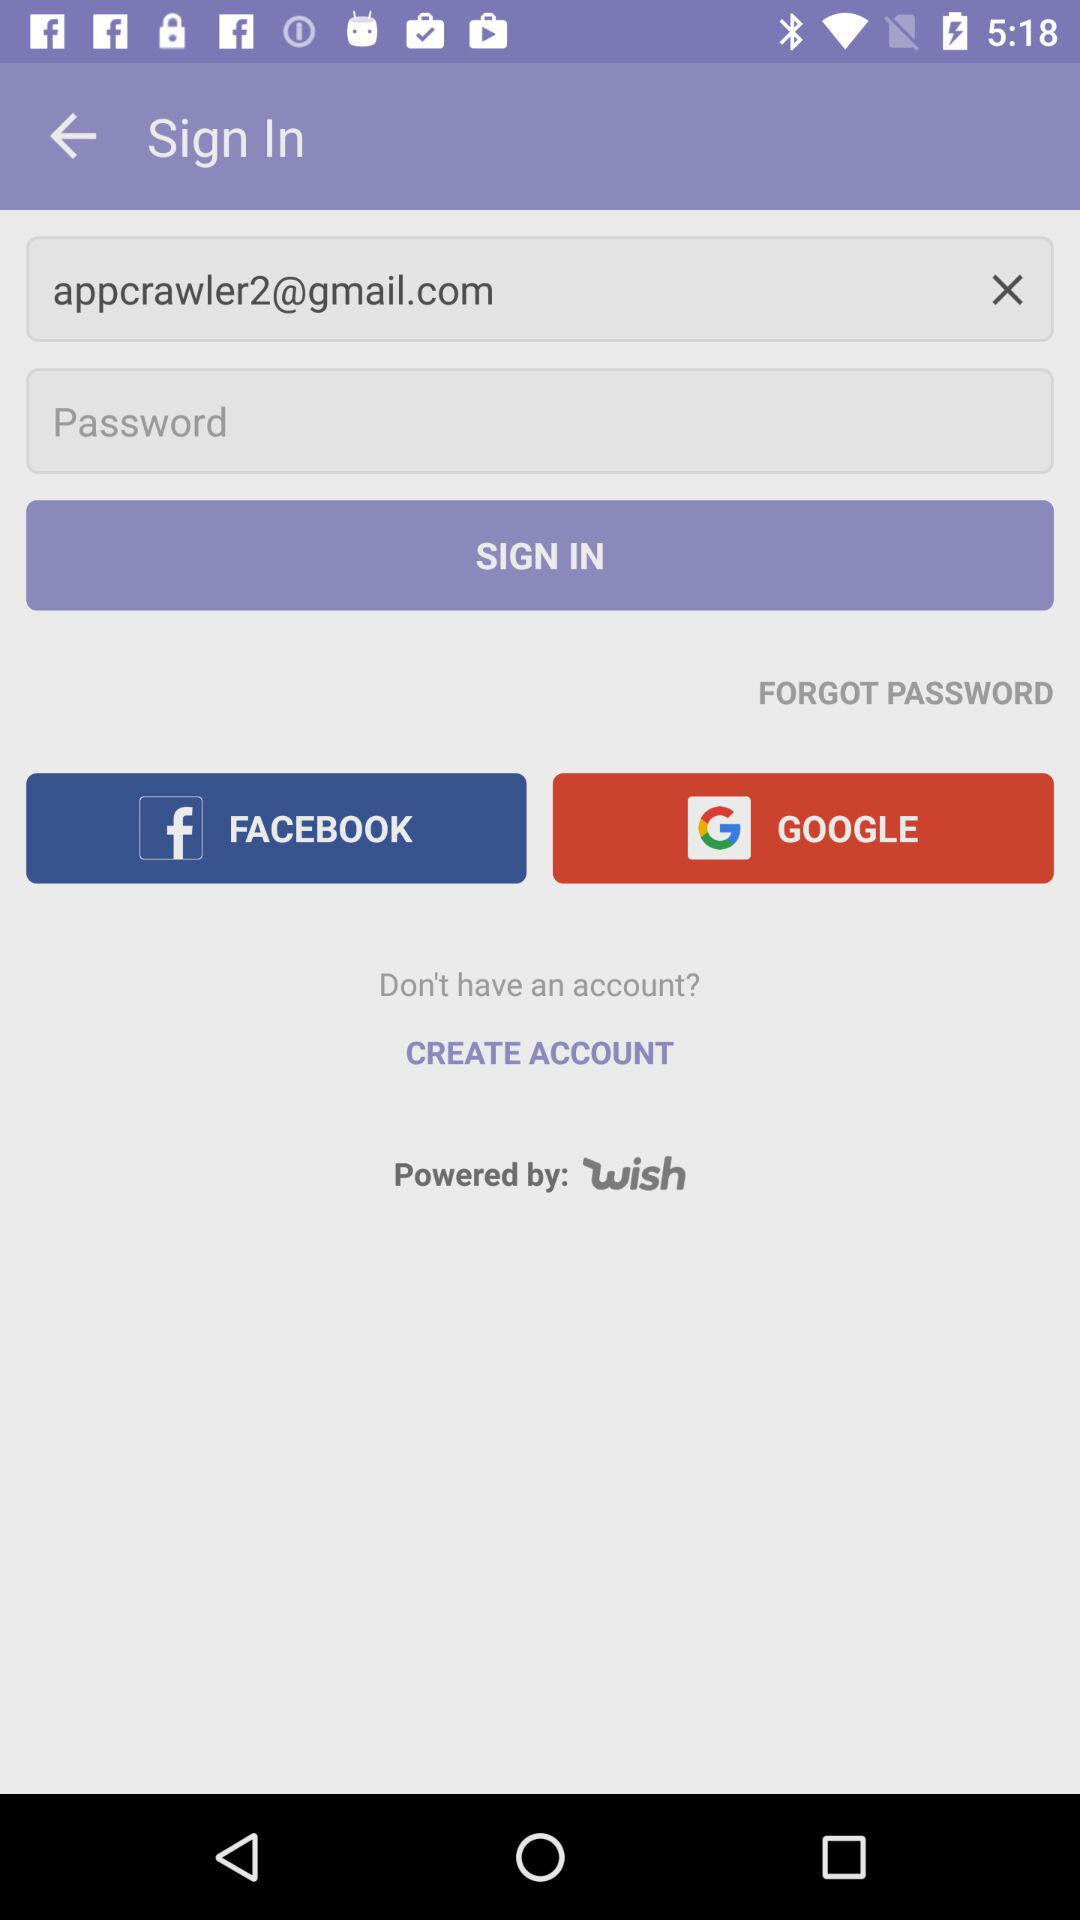What are the different apps to log in? The different apps to log in to are Facebook and Google. 